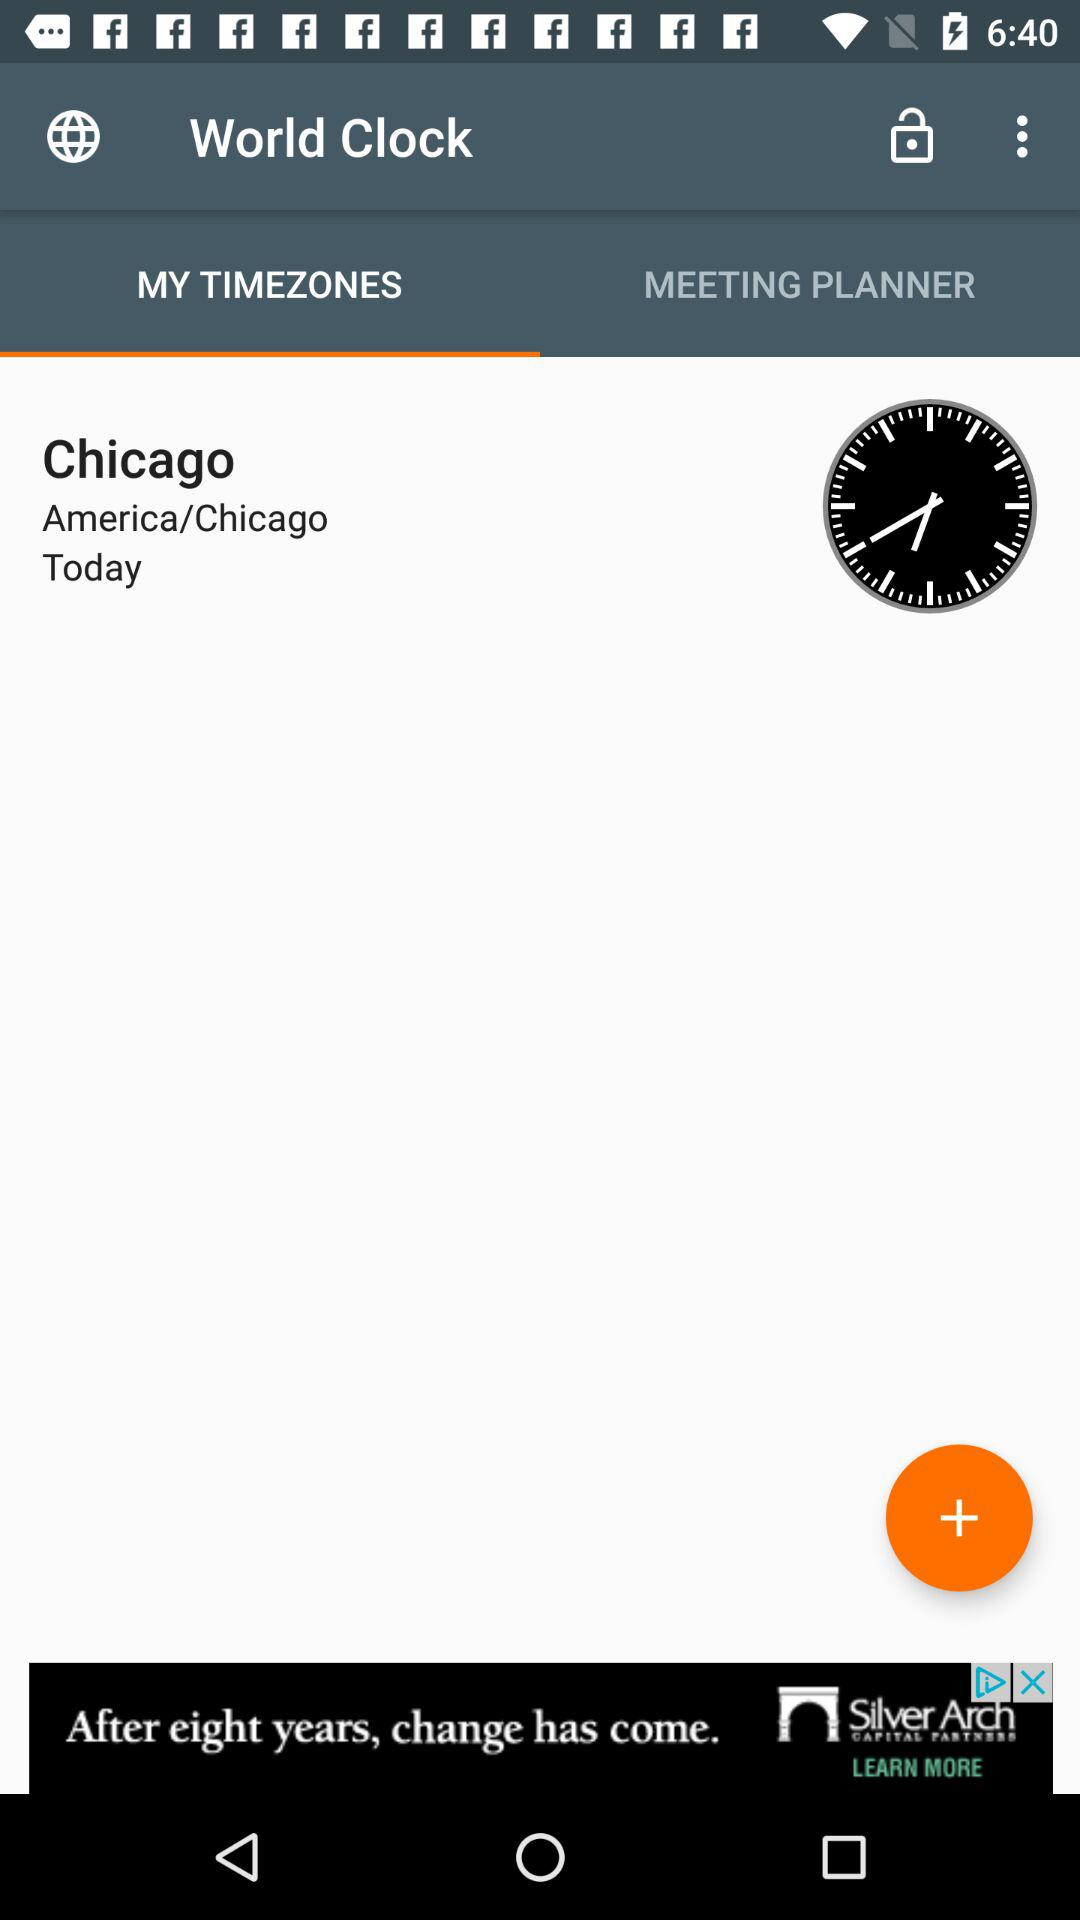What country time has been shown on the screen? The country is America. 